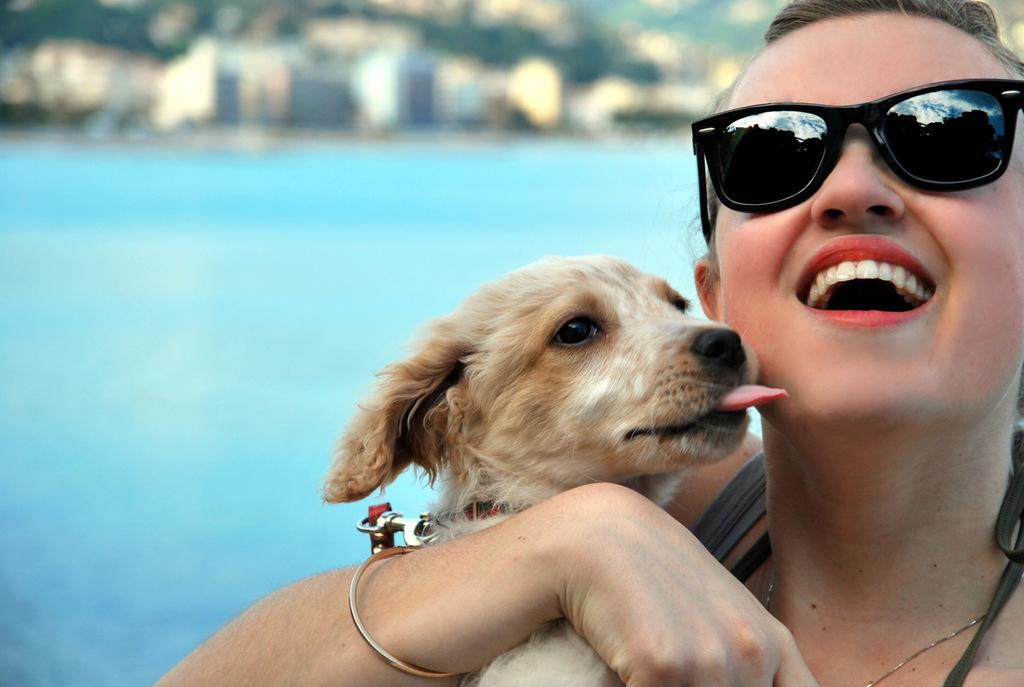What is the woman in the image doing? The woman is holding a dog in the image. What is the woman's expression in the image? The woman is smiling in the image. What can be seen in the background of the image? There is water and trees visible in the background of the image. What caption would best describe the woman's interaction with the dog in the image? There is no caption provided with the image, so it is not possible to determine the best caption for the scene. 